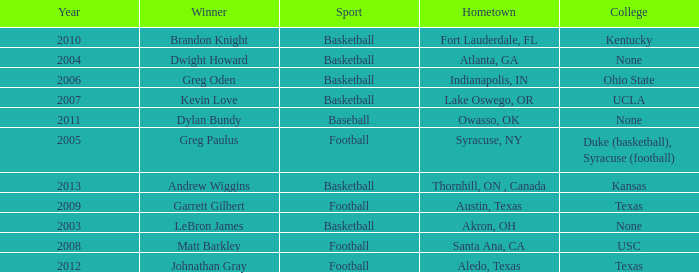What is the total number of Year, when Winner is "Johnathan Gray"? 1.0. 